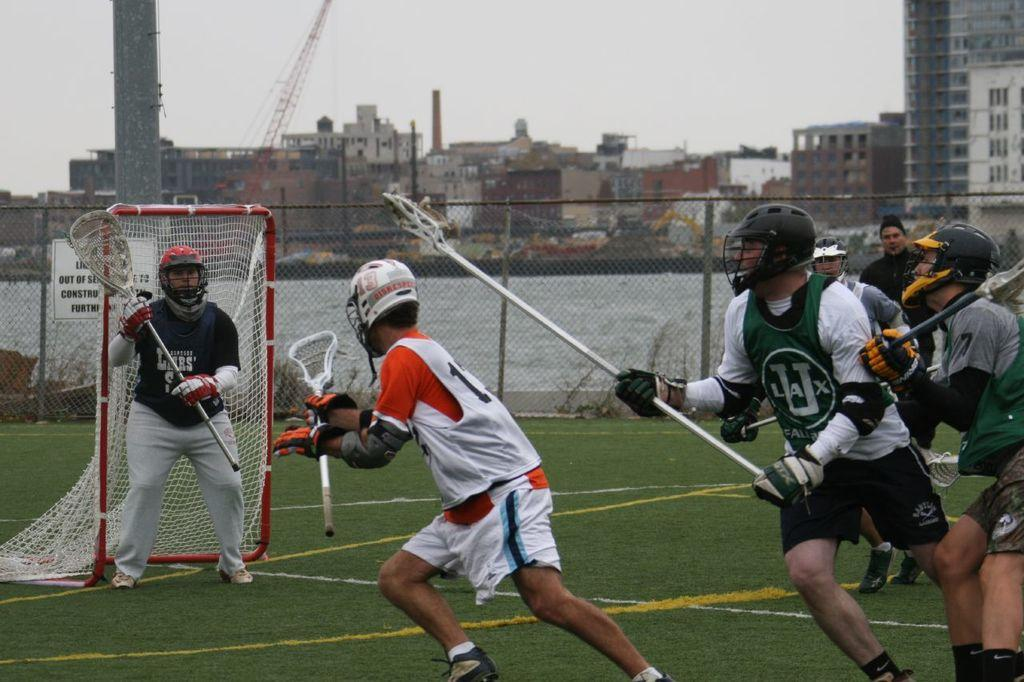<image>
Write a terse but informative summary of the picture. Athletes going for the ball including one with the letters LAX on his jersey. 